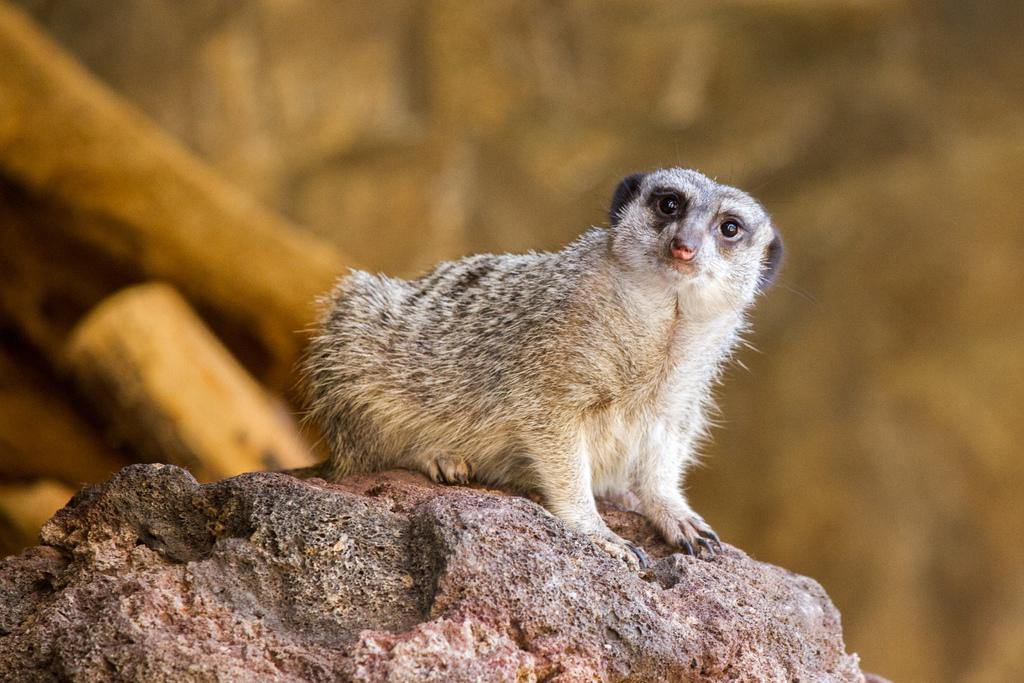What is located at the bottom of the image? There is a rock at the bottom of the image. What is on top of the rock? There is an animal on the rock. What can be seen in the background of the image? There are wooden sticks visible in the background of the image. What type of rabbit is sitting on the rock in the image? There is no rabbit present in the image; it features an animal on a rock. What additional detail can be seen on the animal's fur in the image? There is no additional detail about the animal's fur mentioned in the provided facts, so we cannot answer this question. 